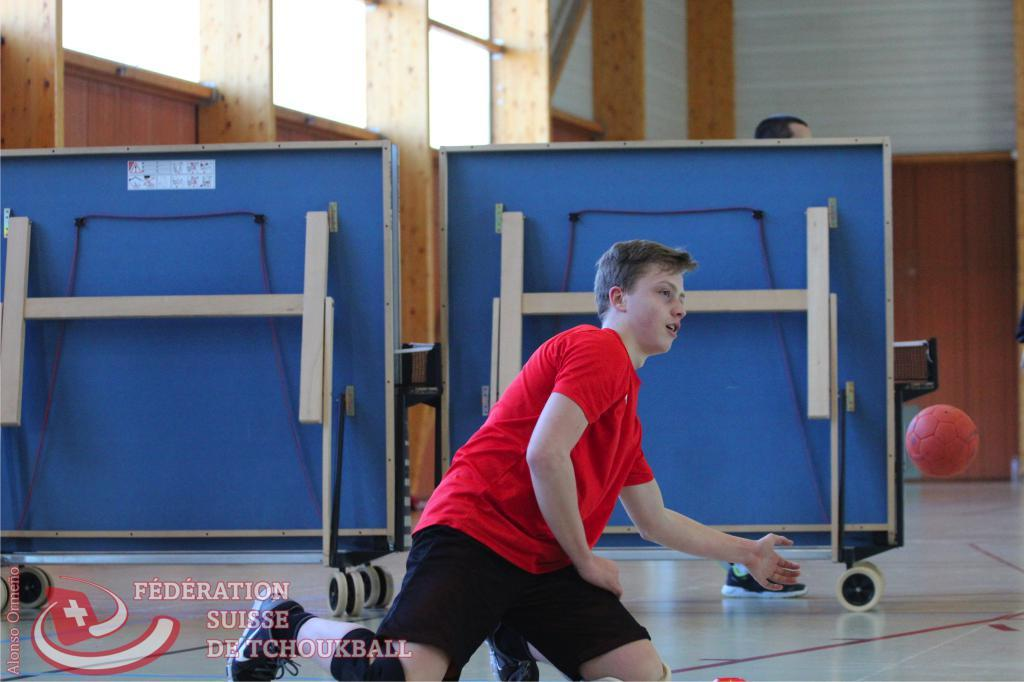<image>
Create a compact narrative representing the image presented. A young man in a red shirt is playing a sport with a red ball for the Federation Suiise Detchoukball. 